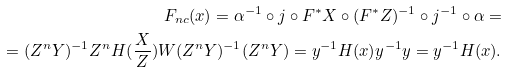Convert formula to latex. <formula><loc_0><loc_0><loc_500><loc_500>F _ { n c } ( x ) = \alpha ^ { - 1 } \circ j \circ F ^ { * } X \circ ( F ^ { * } Z ) ^ { - 1 } \circ j ^ { - 1 } \circ \alpha = \\ = ( Z ^ { n } Y ) ^ { - 1 } Z ^ { n } H ( \frac { X } { Z } ) W ( Z ^ { n } Y ) ^ { - 1 } ( Z ^ { n } Y ) = y ^ { - 1 } H ( x ) y ^ { - 1 } y = y ^ { - 1 } H ( x ) .</formula> 